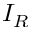<formula> <loc_0><loc_0><loc_500><loc_500>I _ { R }</formula> 